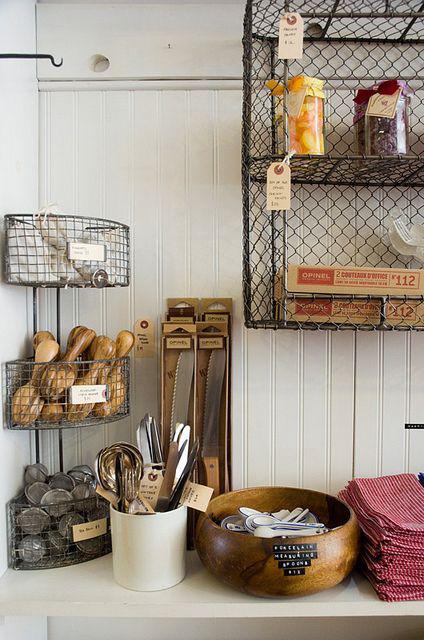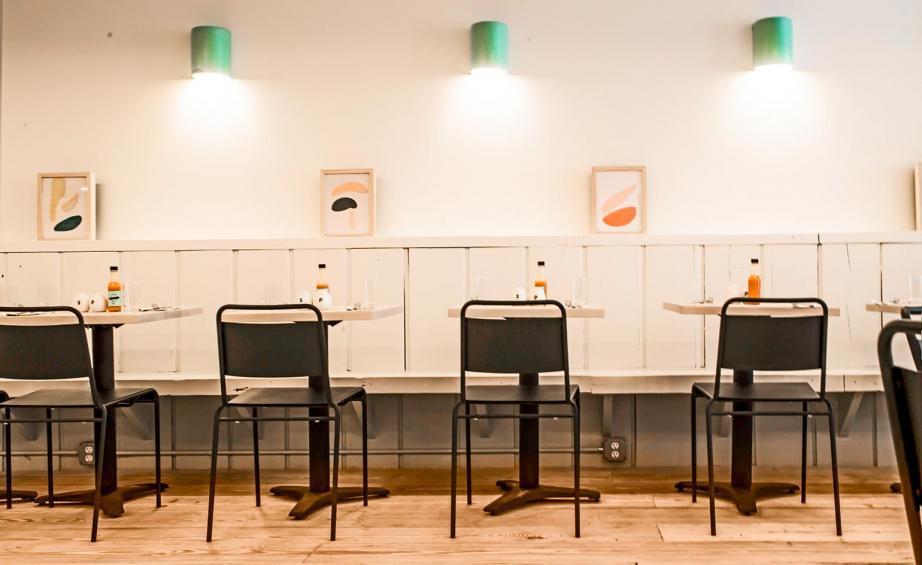The first image is the image on the left, the second image is the image on the right. Examine the images to the left and right. Is the description "There are chairs in both images." accurate? Answer yes or no. No. 